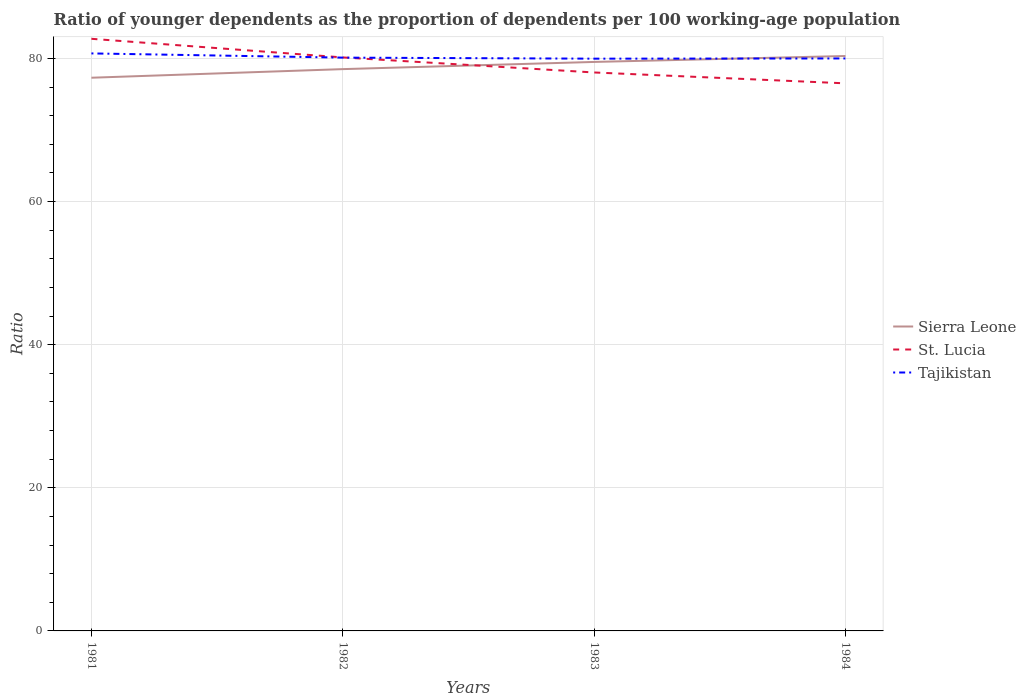Across all years, what is the maximum age dependency ratio(young) in Sierra Leone?
Your answer should be compact. 77.3. What is the total age dependency ratio(young) in St. Lucia in the graph?
Offer a very short reply. 4.7. What is the difference between the highest and the second highest age dependency ratio(young) in Sierra Leone?
Provide a succinct answer. 3.04. How many lines are there?
Offer a terse response. 3. Does the graph contain grids?
Keep it short and to the point. Yes. What is the title of the graph?
Your response must be concise. Ratio of younger dependents as the proportion of dependents per 100 working-age population. Does "Georgia" appear as one of the legend labels in the graph?
Keep it short and to the point. No. What is the label or title of the Y-axis?
Ensure brevity in your answer.  Ratio. What is the Ratio in Sierra Leone in 1981?
Ensure brevity in your answer.  77.3. What is the Ratio in St. Lucia in 1981?
Provide a succinct answer. 82.74. What is the Ratio in Tajikistan in 1981?
Your response must be concise. 80.7. What is the Ratio of Sierra Leone in 1982?
Your answer should be very brief. 78.5. What is the Ratio in St. Lucia in 1982?
Offer a terse response. 80.14. What is the Ratio in Tajikistan in 1982?
Ensure brevity in your answer.  80.11. What is the Ratio in Sierra Leone in 1983?
Your answer should be very brief. 79.51. What is the Ratio of St. Lucia in 1983?
Ensure brevity in your answer.  78.04. What is the Ratio in Tajikistan in 1983?
Provide a short and direct response. 79.96. What is the Ratio in Sierra Leone in 1984?
Give a very brief answer. 80.34. What is the Ratio in St. Lucia in 1984?
Provide a short and direct response. 76.52. What is the Ratio in Tajikistan in 1984?
Offer a terse response. 79.99. Across all years, what is the maximum Ratio in Sierra Leone?
Offer a terse response. 80.34. Across all years, what is the maximum Ratio of St. Lucia?
Your answer should be compact. 82.74. Across all years, what is the maximum Ratio of Tajikistan?
Keep it short and to the point. 80.7. Across all years, what is the minimum Ratio in Sierra Leone?
Provide a short and direct response. 77.3. Across all years, what is the minimum Ratio in St. Lucia?
Provide a succinct answer. 76.52. Across all years, what is the minimum Ratio in Tajikistan?
Offer a very short reply. 79.96. What is the total Ratio in Sierra Leone in the graph?
Provide a succinct answer. 315.65. What is the total Ratio in St. Lucia in the graph?
Your response must be concise. 317.43. What is the total Ratio in Tajikistan in the graph?
Your answer should be compact. 320.77. What is the difference between the Ratio of Sierra Leone in 1981 and that in 1982?
Provide a succinct answer. -1.2. What is the difference between the Ratio in St. Lucia in 1981 and that in 1982?
Provide a short and direct response. 2.6. What is the difference between the Ratio in Tajikistan in 1981 and that in 1982?
Provide a succinct answer. 0.59. What is the difference between the Ratio of Sierra Leone in 1981 and that in 1983?
Ensure brevity in your answer.  -2.21. What is the difference between the Ratio in St. Lucia in 1981 and that in 1983?
Offer a terse response. 4.7. What is the difference between the Ratio of Tajikistan in 1981 and that in 1983?
Offer a very short reply. 0.73. What is the difference between the Ratio of Sierra Leone in 1981 and that in 1984?
Ensure brevity in your answer.  -3.04. What is the difference between the Ratio of St. Lucia in 1981 and that in 1984?
Your answer should be very brief. 6.22. What is the difference between the Ratio in Tajikistan in 1981 and that in 1984?
Make the answer very short. 0.7. What is the difference between the Ratio of Sierra Leone in 1982 and that in 1983?
Offer a very short reply. -1. What is the difference between the Ratio in St. Lucia in 1982 and that in 1983?
Provide a short and direct response. 2.1. What is the difference between the Ratio of Tajikistan in 1982 and that in 1983?
Offer a very short reply. 0.14. What is the difference between the Ratio in Sierra Leone in 1982 and that in 1984?
Keep it short and to the point. -1.83. What is the difference between the Ratio of St. Lucia in 1982 and that in 1984?
Give a very brief answer. 3.62. What is the difference between the Ratio in Tajikistan in 1982 and that in 1984?
Provide a succinct answer. 0.12. What is the difference between the Ratio of Sierra Leone in 1983 and that in 1984?
Keep it short and to the point. -0.83. What is the difference between the Ratio of St. Lucia in 1983 and that in 1984?
Give a very brief answer. 1.52. What is the difference between the Ratio of Tajikistan in 1983 and that in 1984?
Offer a terse response. -0.03. What is the difference between the Ratio of Sierra Leone in 1981 and the Ratio of St. Lucia in 1982?
Give a very brief answer. -2.84. What is the difference between the Ratio of Sierra Leone in 1981 and the Ratio of Tajikistan in 1982?
Offer a terse response. -2.81. What is the difference between the Ratio of St. Lucia in 1981 and the Ratio of Tajikistan in 1982?
Offer a terse response. 2.63. What is the difference between the Ratio in Sierra Leone in 1981 and the Ratio in St. Lucia in 1983?
Provide a short and direct response. -0.73. What is the difference between the Ratio in Sierra Leone in 1981 and the Ratio in Tajikistan in 1983?
Make the answer very short. -2.66. What is the difference between the Ratio of St. Lucia in 1981 and the Ratio of Tajikistan in 1983?
Offer a very short reply. 2.78. What is the difference between the Ratio in Sierra Leone in 1981 and the Ratio in St. Lucia in 1984?
Offer a terse response. 0.78. What is the difference between the Ratio of Sierra Leone in 1981 and the Ratio of Tajikistan in 1984?
Your response must be concise. -2.69. What is the difference between the Ratio of St. Lucia in 1981 and the Ratio of Tajikistan in 1984?
Your response must be concise. 2.75. What is the difference between the Ratio in Sierra Leone in 1982 and the Ratio in St. Lucia in 1983?
Keep it short and to the point. 0.47. What is the difference between the Ratio of Sierra Leone in 1982 and the Ratio of Tajikistan in 1983?
Give a very brief answer. -1.46. What is the difference between the Ratio of St. Lucia in 1982 and the Ratio of Tajikistan in 1983?
Your answer should be compact. 0.17. What is the difference between the Ratio in Sierra Leone in 1982 and the Ratio in St. Lucia in 1984?
Keep it short and to the point. 1.99. What is the difference between the Ratio in Sierra Leone in 1982 and the Ratio in Tajikistan in 1984?
Your answer should be compact. -1.49. What is the difference between the Ratio in St. Lucia in 1982 and the Ratio in Tajikistan in 1984?
Make the answer very short. 0.14. What is the difference between the Ratio in Sierra Leone in 1983 and the Ratio in St. Lucia in 1984?
Offer a very short reply. 2.99. What is the difference between the Ratio of Sierra Leone in 1983 and the Ratio of Tajikistan in 1984?
Keep it short and to the point. -0.49. What is the difference between the Ratio in St. Lucia in 1983 and the Ratio in Tajikistan in 1984?
Provide a short and direct response. -1.96. What is the average Ratio of Sierra Leone per year?
Provide a short and direct response. 78.91. What is the average Ratio in St. Lucia per year?
Provide a succinct answer. 79.36. What is the average Ratio in Tajikistan per year?
Keep it short and to the point. 80.19. In the year 1981, what is the difference between the Ratio in Sierra Leone and Ratio in St. Lucia?
Your response must be concise. -5.44. In the year 1981, what is the difference between the Ratio in Sierra Leone and Ratio in Tajikistan?
Your answer should be very brief. -3.4. In the year 1981, what is the difference between the Ratio in St. Lucia and Ratio in Tajikistan?
Ensure brevity in your answer.  2.04. In the year 1982, what is the difference between the Ratio in Sierra Leone and Ratio in St. Lucia?
Provide a succinct answer. -1.63. In the year 1982, what is the difference between the Ratio in Sierra Leone and Ratio in Tajikistan?
Make the answer very short. -1.61. In the year 1982, what is the difference between the Ratio of St. Lucia and Ratio of Tajikistan?
Offer a very short reply. 0.03. In the year 1983, what is the difference between the Ratio in Sierra Leone and Ratio in St. Lucia?
Your answer should be very brief. 1.47. In the year 1983, what is the difference between the Ratio of Sierra Leone and Ratio of Tajikistan?
Keep it short and to the point. -0.46. In the year 1983, what is the difference between the Ratio of St. Lucia and Ratio of Tajikistan?
Your answer should be compact. -1.93. In the year 1984, what is the difference between the Ratio of Sierra Leone and Ratio of St. Lucia?
Your answer should be very brief. 3.82. In the year 1984, what is the difference between the Ratio in Sierra Leone and Ratio in Tajikistan?
Ensure brevity in your answer.  0.34. In the year 1984, what is the difference between the Ratio of St. Lucia and Ratio of Tajikistan?
Give a very brief answer. -3.48. What is the ratio of the Ratio of Sierra Leone in 1981 to that in 1982?
Your response must be concise. 0.98. What is the ratio of the Ratio of St. Lucia in 1981 to that in 1982?
Offer a very short reply. 1.03. What is the ratio of the Ratio of Tajikistan in 1981 to that in 1982?
Make the answer very short. 1.01. What is the ratio of the Ratio in Sierra Leone in 1981 to that in 1983?
Keep it short and to the point. 0.97. What is the ratio of the Ratio of St. Lucia in 1981 to that in 1983?
Provide a succinct answer. 1.06. What is the ratio of the Ratio in Tajikistan in 1981 to that in 1983?
Offer a terse response. 1.01. What is the ratio of the Ratio in Sierra Leone in 1981 to that in 1984?
Give a very brief answer. 0.96. What is the ratio of the Ratio in St. Lucia in 1981 to that in 1984?
Ensure brevity in your answer.  1.08. What is the ratio of the Ratio in Tajikistan in 1981 to that in 1984?
Ensure brevity in your answer.  1.01. What is the ratio of the Ratio in Sierra Leone in 1982 to that in 1983?
Your answer should be very brief. 0.99. What is the ratio of the Ratio in St. Lucia in 1982 to that in 1983?
Offer a terse response. 1.03. What is the ratio of the Ratio of Sierra Leone in 1982 to that in 1984?
Make the answer very short. 0.98. What is the ratio of the Ratio in St. Lucia in 1982 to that in 1984?
Ensure brevity in your answer.  1.05. What is the ratio of the Ratio in Sierra Leone in 1983 to that in 1984?
Give a very brief answer. 0.99. What is the ratio of the Ratio in St. Lucia in 1983 to that in 1984?
Make the answer very short. 1.02. What is the difference between the highest and the second highest Ratio in Sierra Leone?
Give a very brief answer. 0.83. What is the difference between the highest and the second highest Ratio in St. Lucia?
Your response must be concise. 2.6. What is the difference between the highest and the second highest Ratio of Tajikistan?
Provide a succinct answer. 0.59. What is the difference between the highest and the lowest Ratio in Sierra Leone?
Provide a short and direct response. 3.04. What is the difference between the highest and the lowest Ratio in St. Lucia?
Ensure brevity in your answer.  6.22. What is the difference between the highest and the lowest Ratio in Tajikistan?
Give a very brief answer. 0.73. 